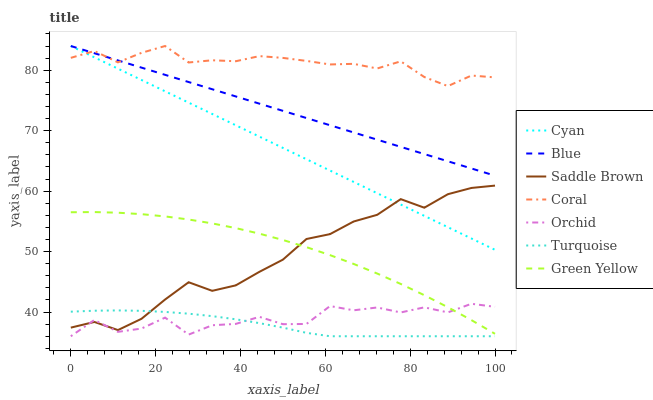Does Turquoise have the minimum area under the curve?
Answer yes or no. Yes. Does Coral have the maximum area under the curve?
Answer yes or no. Yes. Does Coral have the minimum area under the curve?
Answer yes or no. No. Does Turquoise have the maximum area under the curve?
Answer yes or no. No. Is Cyan the smoothest?
Answer yes or no. Yes. Is Orchid the roughest?
Answer yes or no. Yes. Is Turquoise the smoothest?
Answer yes or no. No. Is Turquoise the roughest?
Answer yes or no. No. Does Turquoise have the lowest value?
Answer yes or no. Yes. Does Coral have the lowest value?
Answer yes or no. No. Does Cyan have the highest value?
Answer yes or no. Yes. Does Turquoise have the highest value?
Answer yes or no. No. Is Orchid less than Cyan?
Answer yes or no. Yes. Is Blue greater than Green Yellow?
Answer yes or no. Yes. Does Blue intersect Coral?
Answer yes or no. Yes. Is Blue less than Coral?
Answer yes or no. No. Is Blue greater than Coral?
Answer yes or no. No. Does Orchid intersect Cyan?
Answer yes or no. No. 